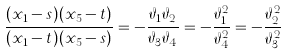Convert formula to latex. <formula><loc_0><loc_0><loc_500><loc_500>\frac { ( x _ { 1 } - s ) ( x _ { 5 } - t ) } { ( x _ { 1 } - t ) ( x _ { 5 } - s ) } = - \frac { \vartheta _ { 1 } \vartheta _ { 2 } } { \vartheta _ { 3 } \vartheta _ { 4 } } = - \frac { \vartheta _ { 1 } ^ { 2 } } { \vartheta _ { 4 } ^ { 2 } } = - \frac { \vartheta _ { 2 } ^ { 2 } } { \vartheta _ { 3 } ^ { 2 } }</formula> 